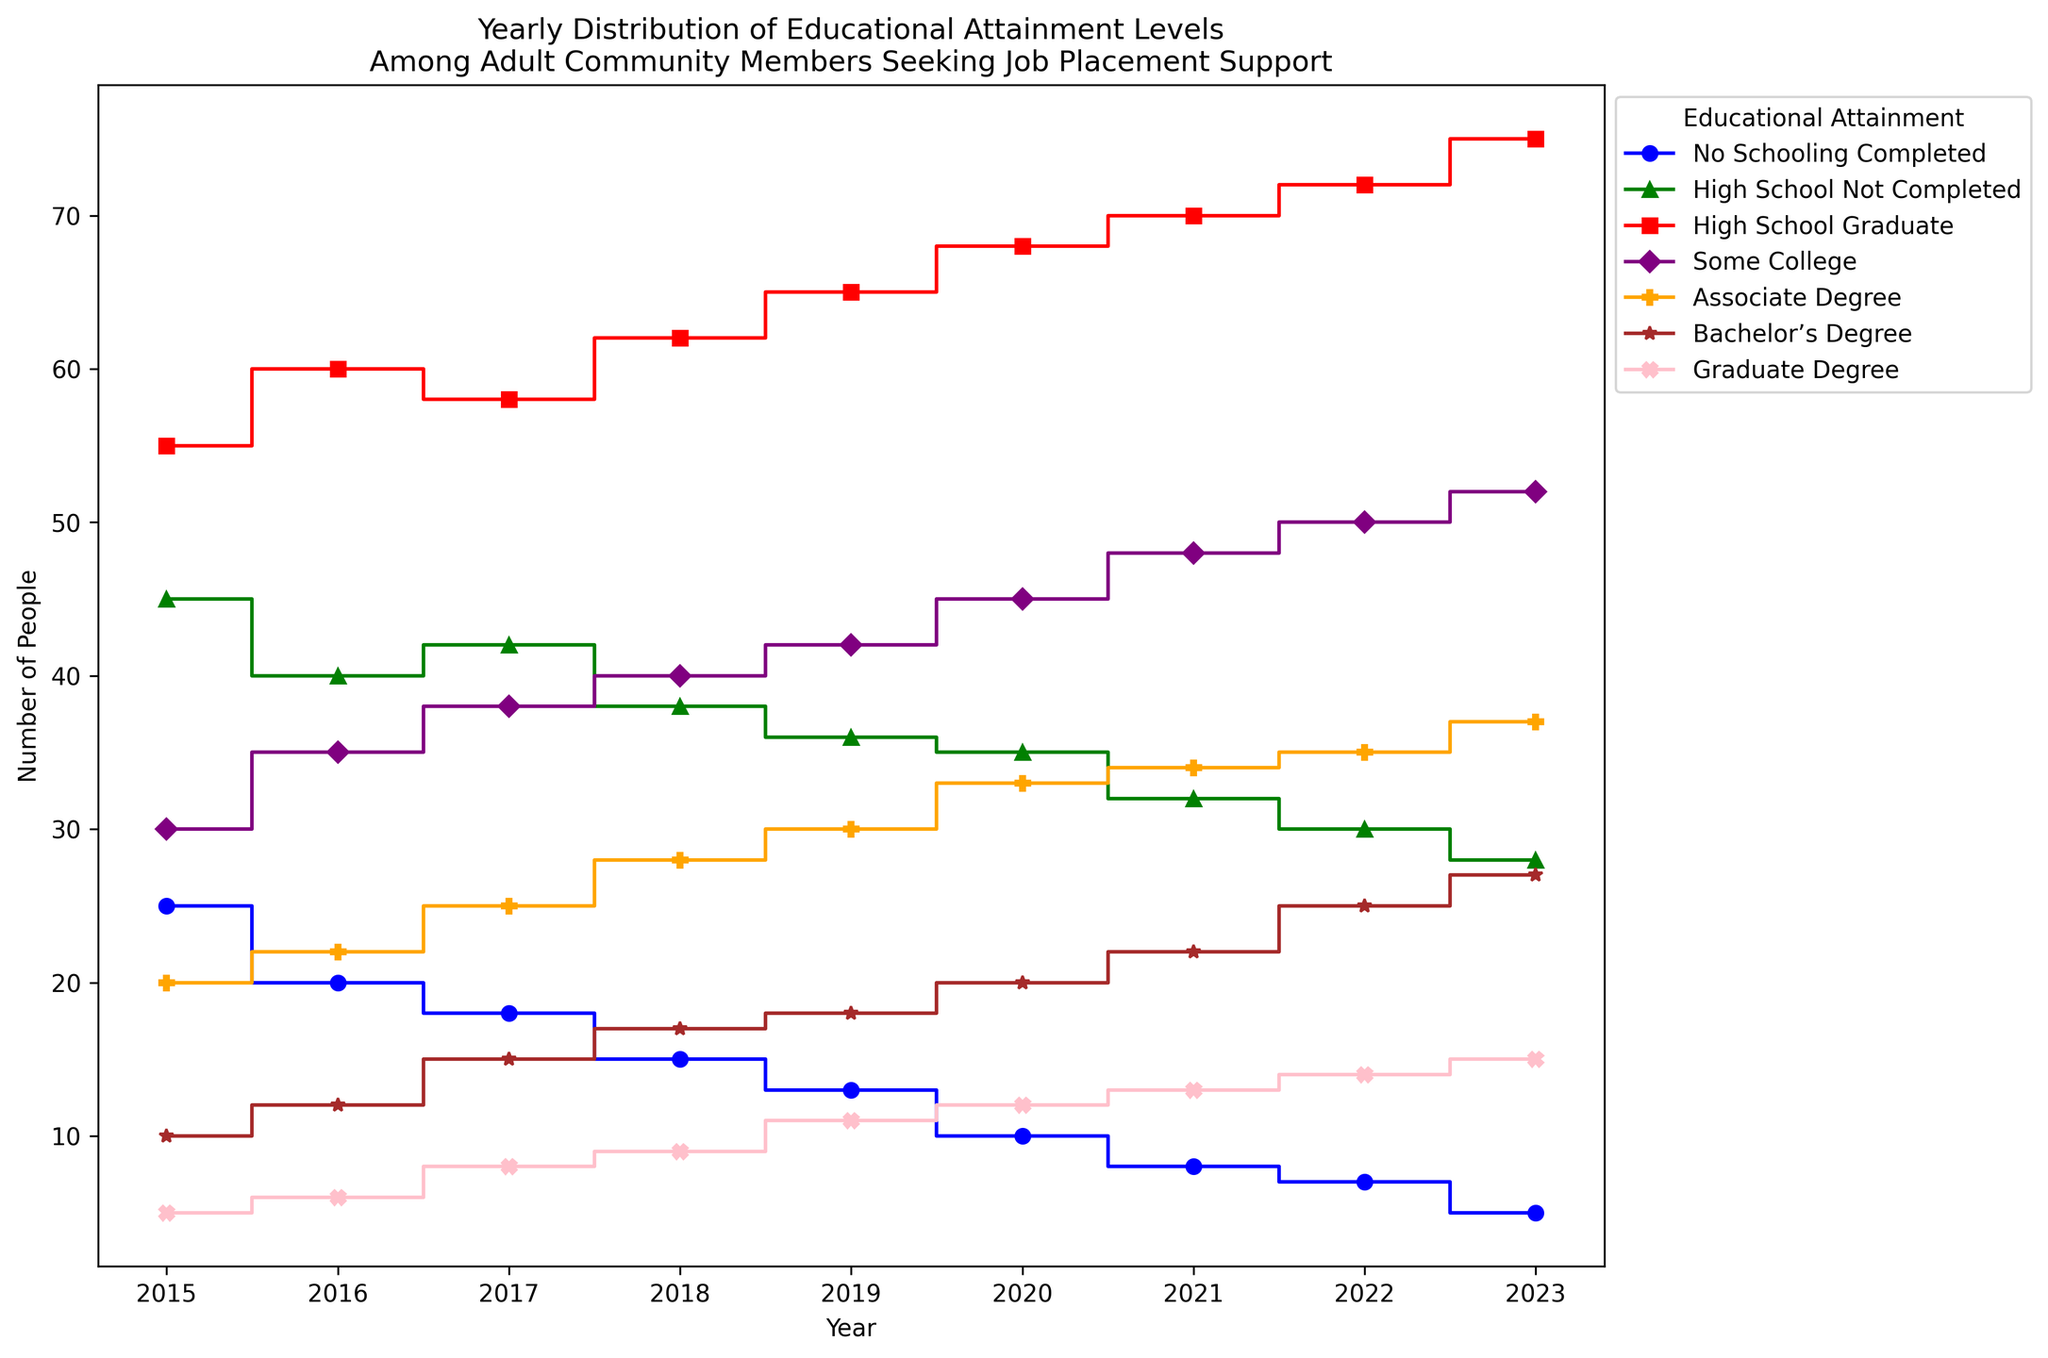What is the trend in the number of people with no schooling completed from 2015 to 2023? The figure displays a decreasing trend for this group, starting at 25 in 2015 and dropping to 5 in 2023. Each year sees a noticeable decline in this number.
Answer: Decreasing In which year did the number of high school graduates peak? The figure shows that the number of high school graduates steadily increases each year, peaking at 75 in 2023.
Answer: 2023 How does the number of people with an associate degree in 2020 compare to those with a bachelor's degree in the same year? The figure depicts the number of people with an associate degree in 2020 as 33, while those with a bachelor's degree are 20. Therefore, there are more people with an associate degree.
Answer: Associate degree > Bachelor's degree Which educational attainment level had the smallest increase over the years? By observing the changes in each attainment level from 2015 to 2023, the number of people with no schooling shows the smallest increase. In fact, it actually decreased from 25 (in 2015) to 5 (in 2023).
Answer: No Schooling Completed What is the average number of people with high school not completed over the entire period? To calculate the average, add the numbers from 2015 to 2023: (45 + 40 + 42 + 38 + 36 + 35 + 32 + 30 + 28) = 326. Divide by 9 years: 326/9 ≈ 36.22
Answer: 36.22 Compare the number of people with graduate degrees in 2015 and 2023. Is there an increase or decrease, and by how much? The figure shows that in 2015, the number was 5, and in 2023, it was 15. The increase is calculated as 15 - 5 = 10.
Answer: Increase by 10 In which year was the number of people with some college education first higher than those with no schooling completed? The figure shows that in 2015, those with some college education were already higher (30) compared to those with no schooling completed (25).
Answer: 2015 Which educational level consistently saw an increase in numbers every year? Observing the plot, the 'High School Graduate' group increases in count from 55 in 2015 to 75 in 2023 every year without a decrease.
Answer: High School Graduate 